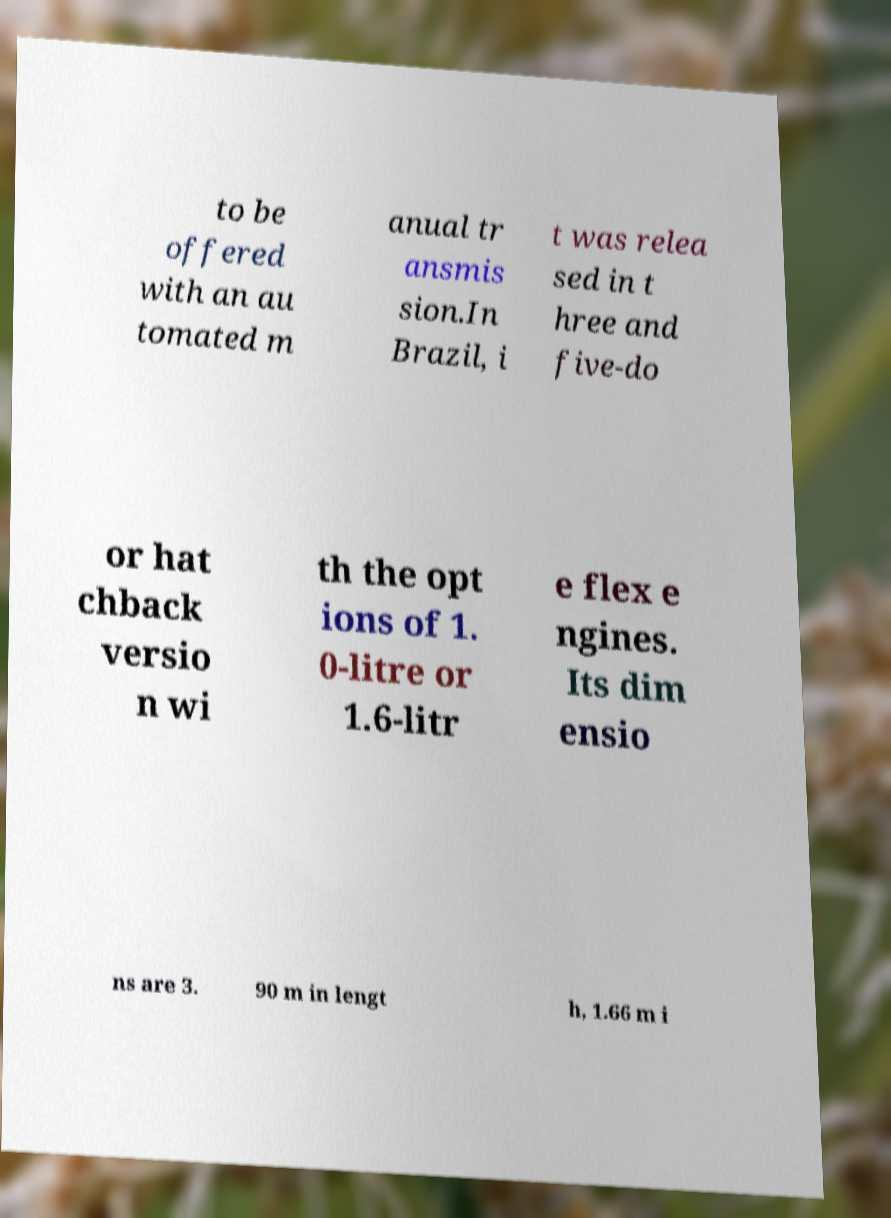For documentation purposes, I need the text within this image transcribed. Could you provide that? to be offered with an au tomated m anual tr ansmis sion.In Brazil, i t was relea sed in t hree and five-do or hat chback versio n wi th the opt ions of 1. 0-litre or 1.6-litr e flex e ngines. Its dim ensio ns are 3. 90 m in lengt h, 1.66 m i 